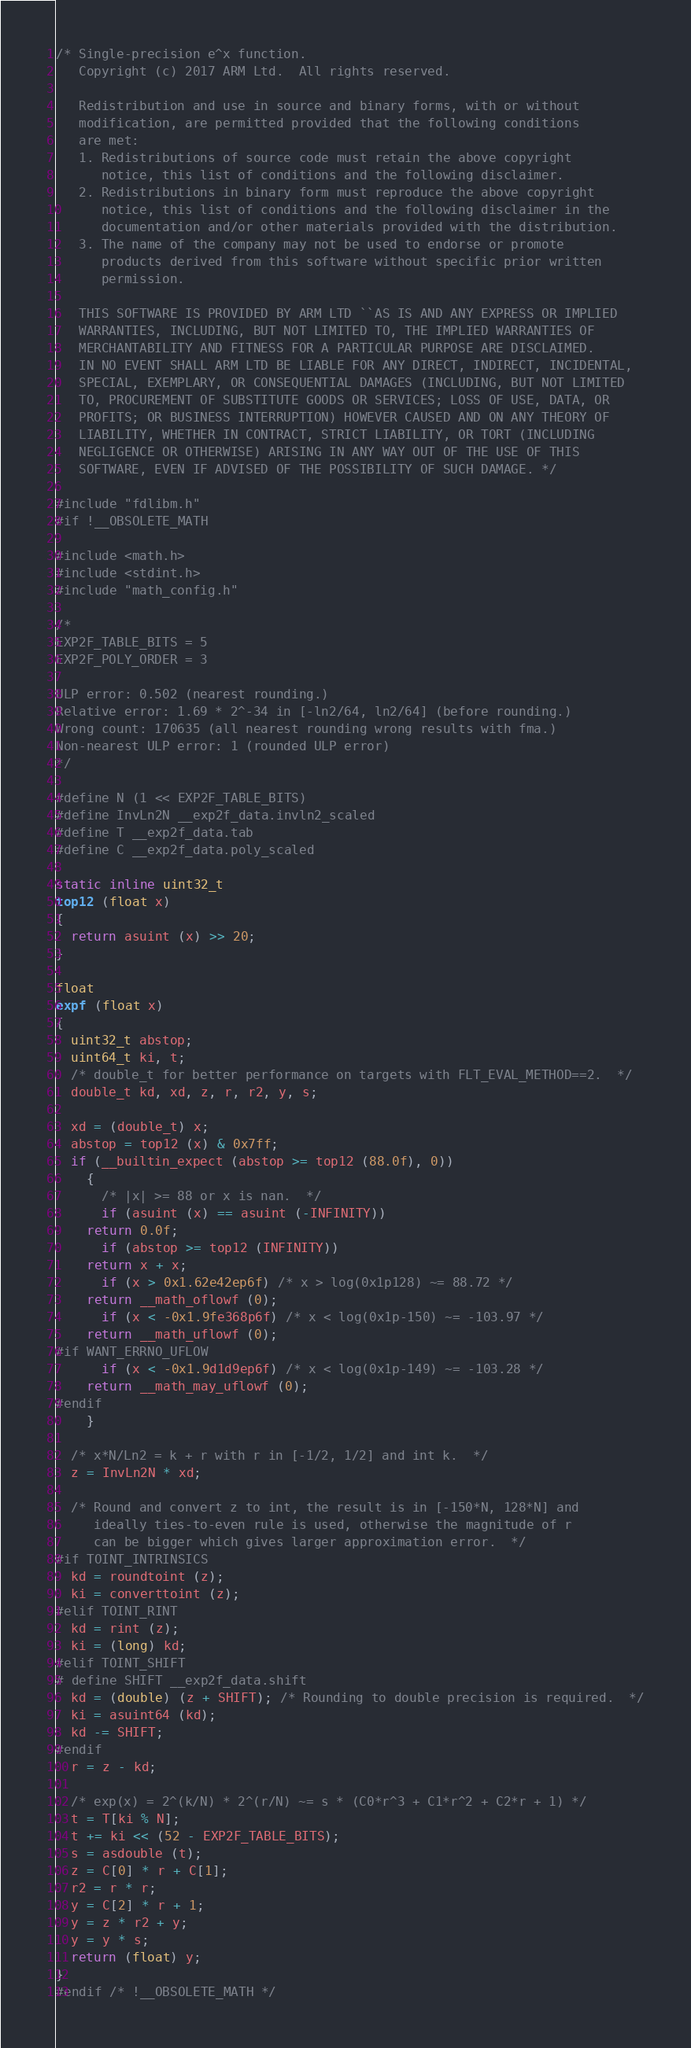<code> <loc_0><loc_0><loc_500><loc_500><_C_>/* Single-precision e^x function.
   Copyright (c) 2017 ARM Ltd.  All rights reserved.

   Redistribution and use in source and binary forms, with or without
   modification, are permitted provided that the following conditions
   are met:
   1. Redistributions of source code must retain the above copyright
      notice, this list of conditions and the following disclaimer.
   2. Redistributions in binary form must reproduce the above copyright
      notice, this list of conditions and the following disclaimer in the
      documentation and/or other materials provided with the distribution.
   3. The name of the company may not be used to endorse or promote
      products derived from this software without specific prior written
      permission.

   THIS SOFTWARE IS PROVIDED BY ARM LTD ``AS IS AND ANY EXPRESS OR IMPLIED
   WARRANTIES, INCLUDING, BUT NOT LIMITED TO, THE IMPLIED WARRANTIES OF
   MERCHANTABILITY AND FITNESS FOR A PARTICULAR PURPOSE ARE DISCLAIMED.
   IN NO EVENT SHALL ARM LTD BE LIABLE FOR ANY DIRECT, INDIRECT, INCIDENTAL,
   SPECIAL, EXEMPLARY, OR CONSEQUENTIAL DAMAGES (INCLUDING, BUT NOT LIMITED
   TO, PROCUREMENT OF SUBSTITUTE GOODS OR SERVICES; LOSS OF USE, DATA, OR
   PROFITS; OR BUSINESS INTERRUPTION) HOWEVER CAUSED AND ON ANY THEORY OF
   LIABILITY, WHETHER IN CONTRACT, STRICT LIABILITY, OR TORT (INCLUDING
   NEGLIGENCE OR OTHERWISE) ARISING IN ANY WAY OUT OF THE USE OF THIS
   SOFTWARE, EVEN IF ADVISED OF THE POSSIBILITY OF SUCH DAMAGE. */

#include "fdlibm.h"
#if !__OBSOLETE_MATH

#include <math.h>
#include <stdint.h>
#include "math_config.h"

/*
EXP2F_TABLE_BITS = 5
EXP2F_POLY_ORDER = 3

ULP error: 0.502 (nearest rounding.)
Relative error: 1.69 * 2^-34 in [-ln2/64, ln2/64] (before rounding.)
Wrong count: 170635 (all nearest rounding wrong results with fma.)
Non-nearest ULP error: 1 (rounded ULP error)
*/

#define N (1 << EXP2F_TABLE_BITS)
#define InvLn2N __exp2f_data.invln2_scaled
#define T __exp2f_data.tab
#define C __exp2f_data.poly_scaled

static inline uint32_t
top12 (float x)
{
  return asuint (x) >> 20;
}

float
expf (float x)
{
  uint32_t abstop;
  uint64_t ki, t;
  /* double_t for better performance on targets with FLT_EVAL_METHOD==2.  */
  double_t kd, xd, z, r, r2, y, s;

  xd = (double_t) x;
  abstop = top12 (x) & 0x7ff;
  if (__builtin_expect (abstop >= top12 (88.0f), 0))
    {
      /* |x| >= 88 or x is nan.  */
      if (asuint (x) == asuint (-INFINITY))
	return 0.0f;
      if (abstop >= top12 (INFINITY))
	return x + x;
      if (x > 0x1.62e42ep6f) /* x > log(0x1p128) ~= 88.72 */
	return __math_oflowf (0);
      if (x < -0x1.9fe368p6f) /* x < log(0x1p-150) ~= -103.97 */
	return __math_uflowf (0);
#if WANT_ERRNO_UFLOW
      if (x < -0x1.9d1d9ep6f) /* x < log(0x1p-149) ~= -103.28 */
	return __math_may_uflowf (0);
#endif
    }

  /* x*N/Ln2 = k + r with r in [-1/2, 1/2] and int k.  */
  z = InvLn2N * xd;

  /* Round and convert z to int, the result is in [-150*N, 128*N] and
     ideally ties-to-even rule is used, otherwise the magnitude of r
     can be bigger which gives larger approximation error.  */
#if TOINT_INTRINSICS
  kd = roundtoint (z);
  ki = converttoint (z);
#elif TOINT_RINT
  kd = rint (z);
  ki = (long) kd;
#elif TOINT_SHIFT
# define SHIFT __exp2f_data.shift
  kd = (double) (z + SHIFT); /* Rounding to double precision is required.  */
  ki = asuint64 (kd);
  kd -= SHIFT;
#endif
  r = z - kd;

  /* exp(x) = 2^(k/N) * 2^(r/N) ~= s * (C0*r^3 + C1*r^2 + C2*r + 1) */
  t = T[ki % N];
  t += ki << (52 - EXP2F_TABLE_BITS);
  s = asdouble (t);
  z = C[0] * r + C[1];
  r2 = r * r;
  y = C[2] * r + 1;
  y = z * r2 + y;
  y = y * s;
  return (float) y;
}
#endif /* !__OBSOLETE_MATH */
</code> 